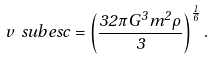Convert formula to latex. <formula><loc_0><loc_0><loc_500><loc_500>v \ s u b { e s c } = \left ( \frac { 3 2 \pi G ^ { 3 } m ^ { 2 } \rho } { 3 } \right ) ^ { \frac { 1 } { 6 } } .</formula> 